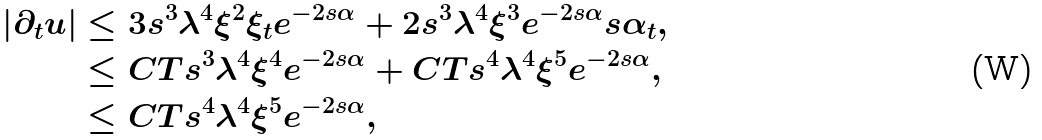Convert formula to latex. <formula><loc_0><loc_0><loc_500><loc_500>| \partial _ { t } u | & \leq 3 s ^ { 3 } \lambda ^ { 4 } \xi ^ { 2 } \xi _ { t } e ^ { - 2 s \alpha } + 2 s ^ { 3 } \lambda ^ { 4 } \xi ^ { 3 } e ^ { - 2 s \alpha } s \alpha _ { t } , \\ & \leq C T s ^ { 3 } \lambda ^ { 4 } \xi ^ { 4 } e ^ { - 2 s \alpha } + C T s ^ { 4 } \lambda ^ { 4 } \xi ^ { 5 } e ^ { - 2 s \alpha } , \\ & \leq C T s ^ { 4 } \lambda ^ { 4 } \xi ^ { 5 } e ^ { - 2 s \alpha } ,</formula> 